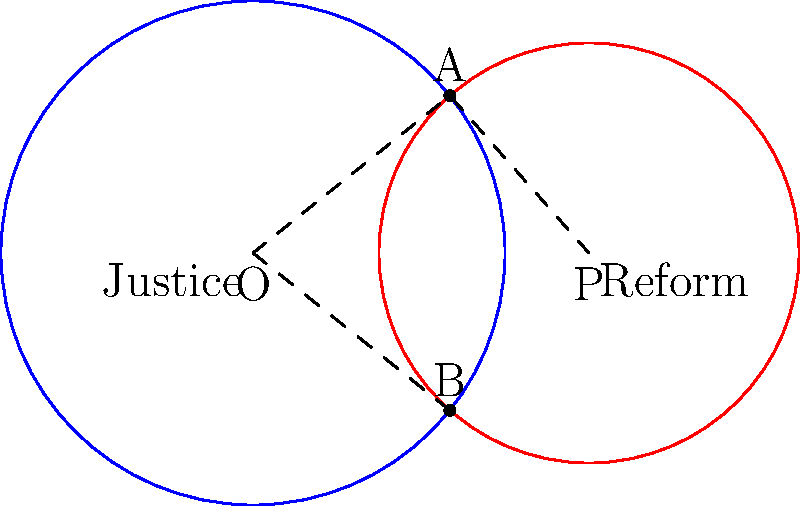In the diagram above, two circles represent "Justice" and "Reform" in the context of prison policy. The circles intersect at points A and B. If the radius of the "Justice" circle is 3 units and the radius of the "Reform" circle is 2.5 units, and the distance between their centers (O and P) is 4 units, what is the area of the overlapping region (in square units)? Round your answer to two decimal places. To find the area of the overlapping region, we need to follow these steps:

1) First, we need to find the central angle of each sector formed in both circles. Let's call these angles $\theta_1$ and $\theta_2$ for the Justice and Reform circles respectively.

2) We can find these angles using the cosine law:
   $$\cos(\frac{\theta_1}{2}) = \frac{4^2 + 3^2 - 2.5^2}{2 \cdot 4 \cdot 3} = 0.7291667$$
   $$\theta_1 = 2 \cdot \arccos(0.7291667) = 1.5390 \text{ radians}$$

   Similarly,
   $$\cos(\frac{\theta_2}{2}) = \frac{4^2 + 2.5^2 - 3^2}{2 \cdot 4 \cdot 2.5} = 0.6875$$
   $$\theta_2 = 2 \cdot \arccos(0.6875) = 1.6956 \text{ radians}$$

3) Now, we can calculate the areas of the sectors:
   $$A_1 = \frac{1}{2} \cdot 3^2 \cdot 1.5390 = 6.9255 \text{ sq units}$$
   $$A_2 = \frac{1}{2} \cdot 2.5^2 \cdot 1.6956 = 5.2987 \text{ sq units}$$

4) Next, we need to find the area of the triangles formed by the intersection points and the centers:
   $$A_{\triangle} = \frac{1}{2} \cdot 4 \cdot 3 \cdot \sin(\frac{\theta_1}{2}) = 2.9001 \text{ sq units}$$

5) The overlapping area is the sum of the sectors minus twice the area of the triangle:
   $$A_{\text{overlap}} = A_1 + A_2 - 2A_{\triangle}$$
   $$A_{\text{overlap}} = 6.9255 + 5.2987 - 2(2.9001) = 6.4240 \text{ sq units}$$

6) Rounding to two decimal places: 6.42 sq units.
Answer: 6.42 sq units 